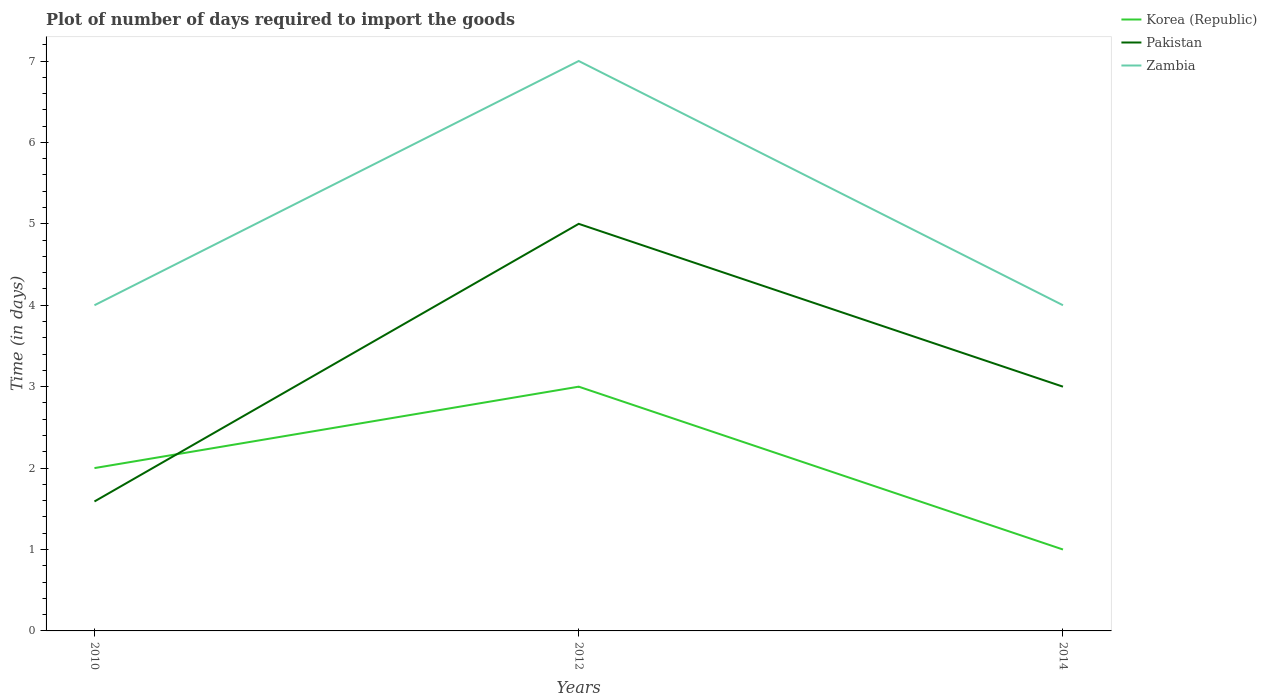Is the number of lines equal to the number of legend labels?
Your response must be concise. Yes. What is the difference between the highest and the second highest time required to import goods in Pakistan?
Keep it short and to the point. 3.41. Are the values on the major ticks of Y-axis written in scientific E-notation?
Ensure brevity in your answer.  No. Does the graph contain any zero values?
Keep it short and to the point. No. Where does the legend appear in the graph?
Provide a succinct answer. Top right. How many legend labels are there?
Ensure brevity in your answer.  3. How are the legend labels stacked?
Offer a terse response. Vertical. What is the title of the graph?
Offer a terse response. Plot of number of days required to import the goods. Does "Venezuela" appear as one of the legend labels in the graph?
Your answer should be very brief. No. What is the label or title of the Y-axis?
Make the answer very short. Time (in days). What is the Time (in days) of Pakistan in 2010?
Your answer should be compact. 1.59. What is the Time (in days) in Korea (Republic) in 2012?
Keep it short and to the point. 3. What is the Time (in days) of Pakistan in 2012?
Your answer should be very brief. 5. What is the Time (in days) in Zambia in 2012?
Keep it short and to the point. 7. What is the Time (in days) of Zambia in 2014?
Offer a very short reply. 4. Across all years, what is the maximum Time (in days) in Korea (Republic)?
Your answer should be compact. 3. Across all years, what is the maximum Time (in days) in Pakistan?
Give a very brief answer. 5. Across all years, what is the maximum Time (in days) of Zambia?
Make the answer very short. 7. Across all years, what is the minimum Time (in days) in Korea (Republic)?
Ensure brevity in your answer.  1. Across all years, what is the minimum Time (in days) of Pakistan?
Your answer should be compact. 1.59. Across all years, what is the minimum Time (in days) in Zambia?
Offer a terse response. 4. What is the total Time (in days) in Pakistan in the graph?
Keep it short and to the point. 9.59. What is the difference between the Time (in days) in Pakistan in 2010 and that in 2012?
Your answer should be compact. -3.41. What is the difference between the Time (in days) in Zambia in 2010 and that in 2012?
Your answer should be very brief. -3. What is the difference between the Time (in days) in Korea (Republic) in 2010 and that in 2014?
Give a very brief answer. 1. What is the difference between the Time (in days) in Pakistan in 2010 and that in 2014?
Provide a short and direct response. -1.41. What is the difference between the Time (in days) of Korea (Republic) in 2010 and the Time (in days) of Pakistan in 2012?
Offer a terse response. -3. What is the difference between the Time (in days) in Korea (Republic) in 2010 and the Time (in days) in Zambia in 2012?
Your answer should be compact. -5. What is the difference between the Time (in days) in Pakistan in 2010 and the Time (in days) in Zambia in 2012?
Keep it short and to the point. -5.41. What is the difference between the Time (in days) in Korea (Republic) in 2010 and the Time (in days) in Pakistan in 2014?
Ensure brevity in your answer.  -1. What is the difference between the Time (in days) in Pakistan in 2010 and the Time (in days) in Zambia in 2014?
Give a very brief answer. -2.41. What is the difference between the Time (in days) in Korea (Republic) in 2012 and the Time (in days) in Pakistan in 2014?
Offer a very short reply. 0. What is the average Time (in days) of Pakistan per year?
Provide a succinct answer. 3.2. In the year 2010, what is the difference between the Time (in days) in Korea (Republic) and Time (in days) in Pakistan?
Offer a very short reply. 0.41. In the year 2010, what is the difference between the Time (in days) in Pakistan and Time (in days) in Zambia?
Provide a short and direct response. -2.41. In the year 2012, what is the difference between the Time (in days) in Korea (Republic) and Time (in days) in Zambia?
Offer a very short reply. -4. In the year 2012, what is the difference between the Time (in days) of Pakistan and Time (in days) of Zambia?
Ensure brevity in your answer.  -2. What is the ratio of the Time (in days) of Korea (Republic) in 2010 to that in 2012?
Make the answer very short. 0.67. What is the ratio of the Time (in days) of Pakistan in 2010 to that in 2012?
Ensure brevity in your answer.  0.32. What is the ratio of the Time (in days) in Pakistan in 2010 to that in 2014?
Offer a very short reply. 0.53. What is the ratio of the Time (in days) in Zambia in 2010 to that in 2014?
Provide a succinct answer. 1. What is the ratio of the Time (in days) in Korea (Republic) in 2012 to that in 2014?
Give a very brief answer. 3. What is the difference between the highest and the second highest Time (in days) of Korea (Republic)?
Provide a short and direct response. 1. What is the difference between the highest and the second highest Time (in days) in Pakistan?
Ensure brevity in your answer.  2. What is the difference between the highest and the lowest Time (in days) in Korea (Republic)?
Keep it short and to the point. 2. What is the difference between the highest and the lowest Time (in days) of Pakistan?
Offer a terse response. 3.41. 